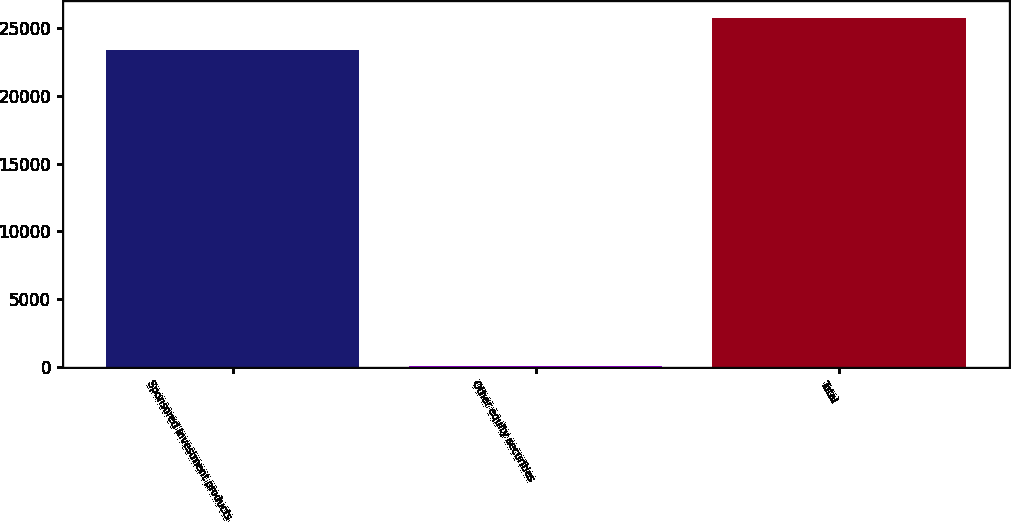Convert chart to OTSL. <chart><loc_0><loc_0><loc_500><loc_500><bar_chart><fcel>Sponsored investment products<fcel>Other equity securities<fcel>Total<nl><fcel>23394<fcel>26<fcel>25733.4<nl></chart> 